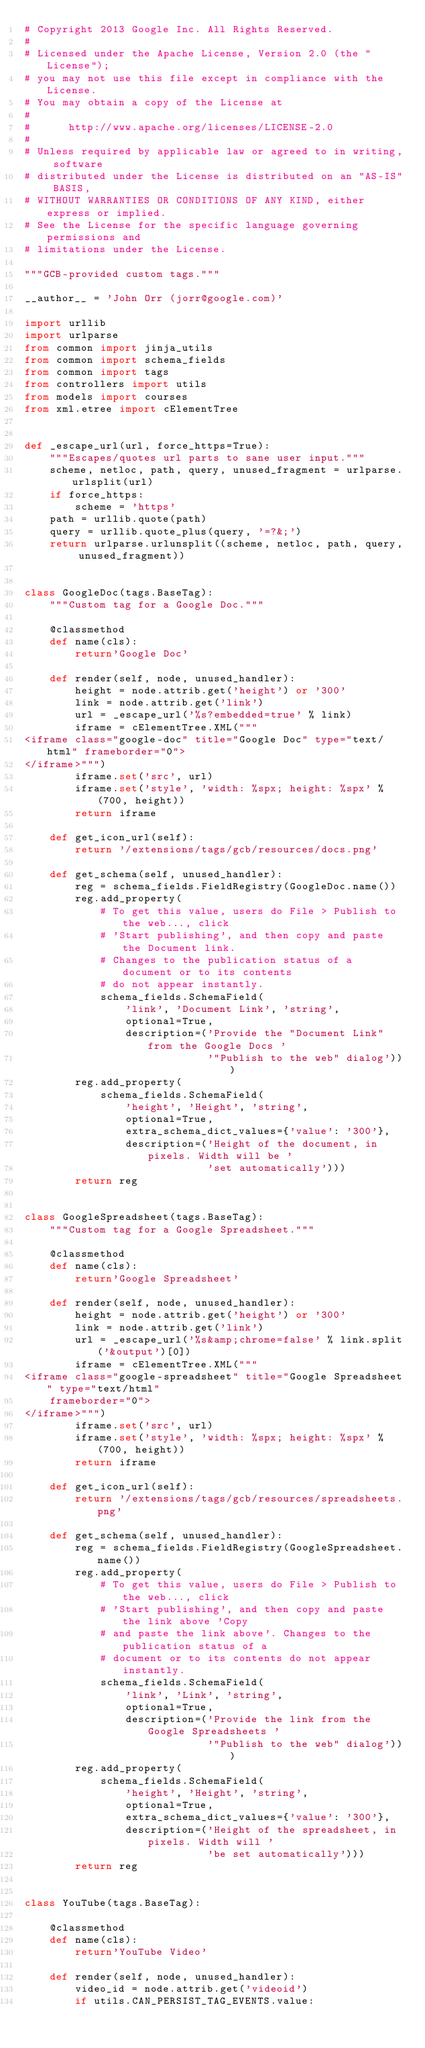<code> <loc_0><loc_0><loc_500><loc_500><_Python_># Copyright 2013 Google Inc. All Rights Reserved.
#
# Licensed under the Apache License, Version 2.0 (the "License");
# you may not use this file except in compliance with the License.
# You may obtain a copy of the License at
#
#      http://www.apache.org/licenses/LICENSE-2.0
#
# Unless required by applicable law or agreed to in writing, software
# distributed under the License is distributed on an "AS-IS" BASIS,
# WITHOUT WARRANTIES OR CONDITIONS OF ANY KIND, either express or implied.
# See the License for the specific language governing permissions and
# limitations under the License.

"""GCB-provided custom tags."""

__author__ = 'John Orr (jorr@google.com)'

import urllib
import urlparse
from common import jinja_utils
from common import schema_fields
from common import tags
from controllers import utils
from models import courses
from xml.etree import cElementTree


def _escape_url(url, force_https=True):
    """Escapes/quotes url parts to sane user input."""
    scheme, netloc, path, query, unused_fragment = urlparse.urlsplit(url)
    if force_https:
        scheme = 'https'
    path = urllib.quote(path)
    query = urllib.quote_plus(query, '=?&;')
    return urlparse.urlunsplit((scheme, netloc, path, query, unused_fragment))


class GoogleDoc(tags.BaseTag):
    """Custom tag for a Google Doc."""

    @classmethod
    def name(cls):
        return'Google Doc'

    def render(self, node, unused_handler):
        height = node.attrib.get('height') or '300'
        link = node.attrib.get('link')
        url = _escape_url('%s?embedded=true' % link)
        iframe = cElementTree.XML("""
<iframe class="google-doc" title="Google Doc" type="text/html" frameborder="0">
</iframe>""")
        iframe.set('src', url)
        iframe.set('style', 'width: %spx; height: %spx' % (700, height))
        return iframe

    def get_icon_url(self):
        return '/extensions/tags/gcb/resources/docs.png'

    def get_schema(self, unused_handler):
        reg = schema_fields.FieldRegistry(GoogleDoc.name())
        reg.add_property(
            # To get this value, users do File > Publish to the web..., click
            # 'Start publishing', and then copy and paste the Document link.
            # Changes to the publication status of a document or to its contents
            # do not appear instantly.
            schema_fields.SchemaField(
                'link', 'Document Link', 'string',
                optional=True,
                description=('Provide the "Document Link" from the Google Docs '
                             '"Publish to the web" dialog')))
        reg.add_property(
            schema_fields.SchemaField(
                'height', 'Height', 'string',
                optional=True,
                extra_schema_dict_values={'value': '300'},
                description=('Height of the document, in pixels. Width will be '
                             'set automatically')))
        return reg


class GoogleSpreadsheet(tags.BaseTag):
    """Custom tag for a Google Spreadsheet."""

    @classmethod
    def name(cls):
        return'Google Spreadsheet'

    def render(self, node, unused_handler):
        height = node.attrib.get('height') or '300'
        link = node.attrib.get('link')
        url = _escape_url('%s&amp;chrome=false' % link.split('&output')[0])
        iframe = cElementTree.XML("""
<iframe class="google-spreadsheet" title="Google Spreadsheet" type="text/html"
    frameborder="0">
</iframe>""")
        iframe.set('src', url)
        iframe.set('style', 'width: %spx; height: %spx' % (700, height))
        return iframe

    def get_icon_url(self):
        return '/extensions/tags/gcb/resources/spreadsheets.png'

    def get_schema(self, unused_handler):
        reg = schema_fields.FieldRegistry(GoogleSpreadsheet.name())
        reg.add_property(
            # To get this value, users do File > Publish to the web..., click
            # 'Start publishing', and then copy and paste the link above 'Copy
            # and paste the link above'. Changes to the publication status of a
            # document or to its contents do not appear instantly.
            schema_fields.SchemaField(
                'link', 'Link', 'string',
                optional=True,
                description=('Provide the link from the Google Spreadsheets '
                             '"Publish to the web" dialog')))
        reg.add_property(
            schema_fields.SchemaField(
                'height', 'Height', 'string',
                optional=True,
                extra_schema_dict_values={'value': '300'},
                description=('Height of the spreadsheet, in pixels. Width will '
                             'be set automatically')))
        return reg


class YouTube(tags.BaseTag):

    @classmethod
    def name(cls):
        return'YouTube Video'

    def render(self, node, unused_handler):
        video_id = node.attrib.get('videoid')
        if utils.CAN_PERSIST_TAG_EVENTS.value:</code> 